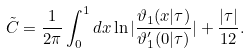<formula> <loc_0><loc_0><loc_500><loc_500>\tilde { C } = \frac { 1 } { 2 \pi } \int _ { 0 } ^ { 1 } d x \ln | \frac { \vartheta _ { 1 } ( x | \tau ) } { \vartheta _ { 1 } ^ { \prime } ( 0 | \tau ) } | + \frac { | \tau | } { 1 2 } .</formula> 